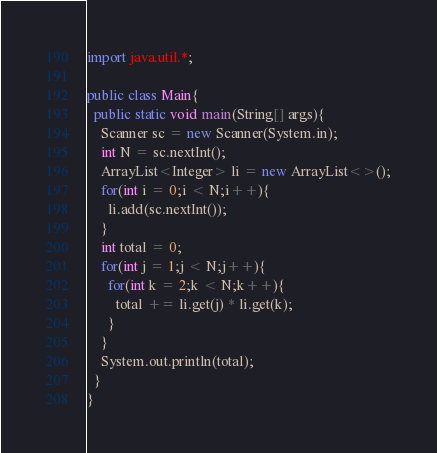<code> <loc_0><loc_0><loc_500><loc_500><_Java_>import java.util.*;

public class Main{
  public static void main(String[] args){
    Scanner sc = new Scanner(System.in);
    int N = sc.nextInt();
    ArrayList<Integer> li = new ArrayList<>();
    for(int i = 0;i < N;i++){
      li.add(sc.nextInt());
    }
    int total = 0;
    for(int j = 1;j < N;j++){
      for(int k = 2;k < N;k++){
        total += li.get(j) * li.get(k);
      }
    }
    System.out.println(total);
  }
}
</code> 